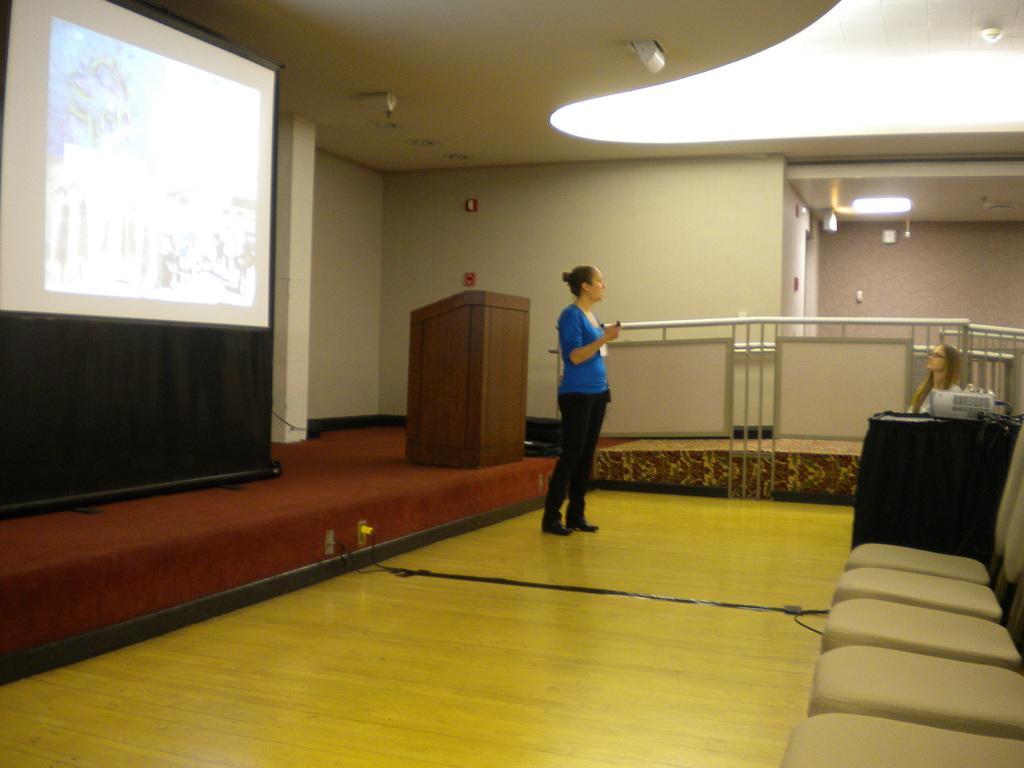In one or two sentences, can you explain what this image depicts? In this image there is a woman standing. To the right there are chairs. There is another woman sitting on the chair. To the left there is a dais. There is a wooden podium on the dais. In the top left there is a projector board hanging to the wall. Behind them there is a railing. In the background there is the wall. At the top there are ceilings to the ceiling, At the bottom there is the floor. 